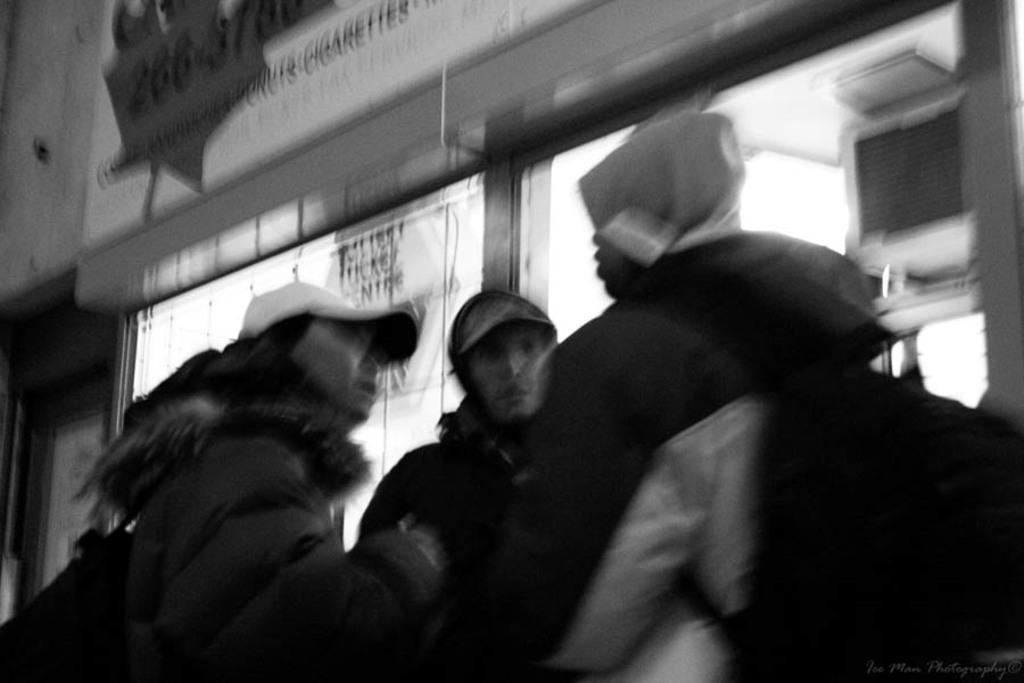Can you describe this image briefly? In the picture I can see people who are wearing hats. This picture is black and white in color. 